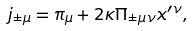<formula> <loc_0><loc_0><loc_500><loc_500>j _ { \pm \mu } = \pi _ { \mu } + 2 \kappa \Pi _ { \pm \mu \nu } x ^ { \prime \nu } ,</formula> 